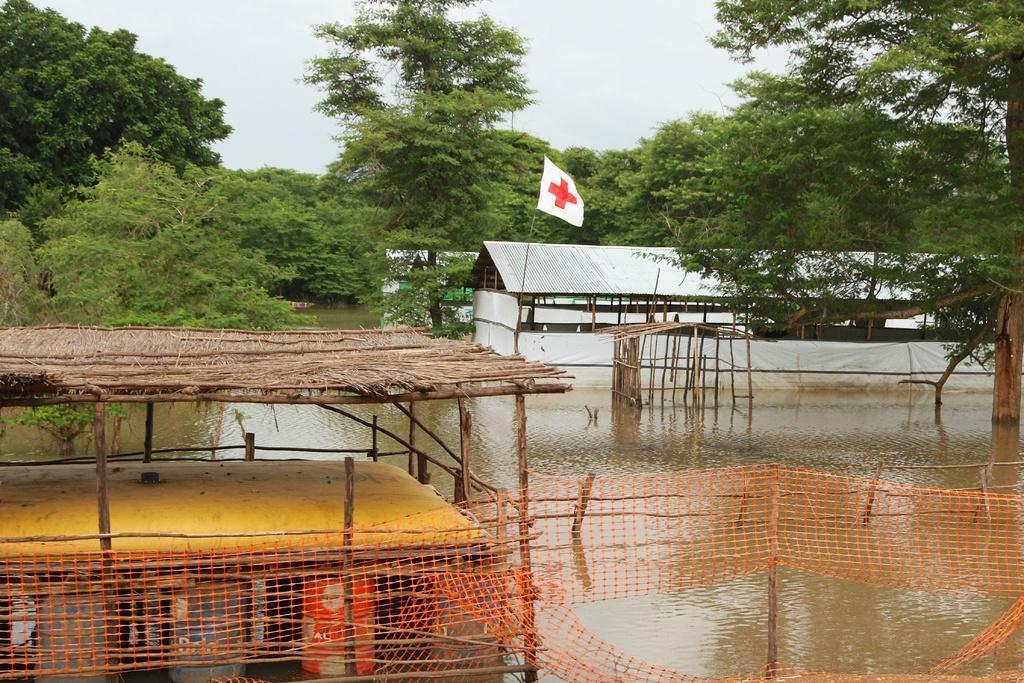Could you give a brief overview of what you see in this image? In the picture we can see a shed on the water with bamboo sticks and under it we can see a yellow color surface and beside the shed we can see net in the water to the poles and behind it we can see a shed in the water and on the top of it we can see a flag with red cross symbol on it and in the background we can see many trees and sky. 